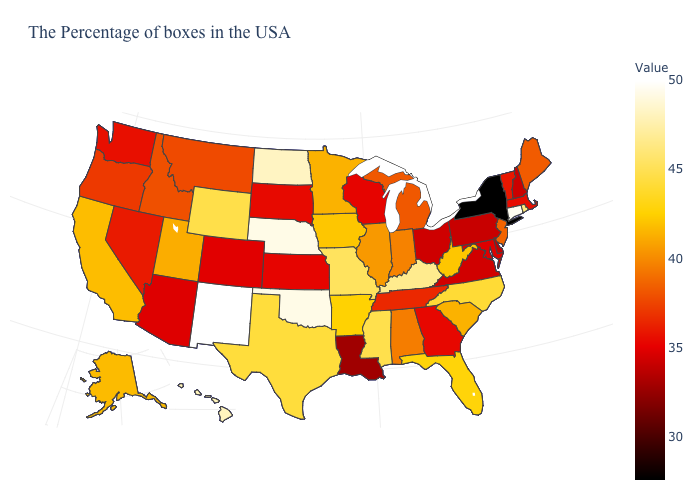Which states hav the highest value in the South?
Give a very brief answer. Oklahoma. Which states hav the highest value in the MidWest?
Quick response, please. Nebraska. Does Michigan have the lowest value in the USA?
Concise answer only. No. Among the states that border Illinois , does Missouri have the lowest value?
Give a very brief answer. No. Is the legend a continuous bar?
Keep it brief. Yes. Which states have the lowest value in the MidWest?
Answer briefly. Ohio. 